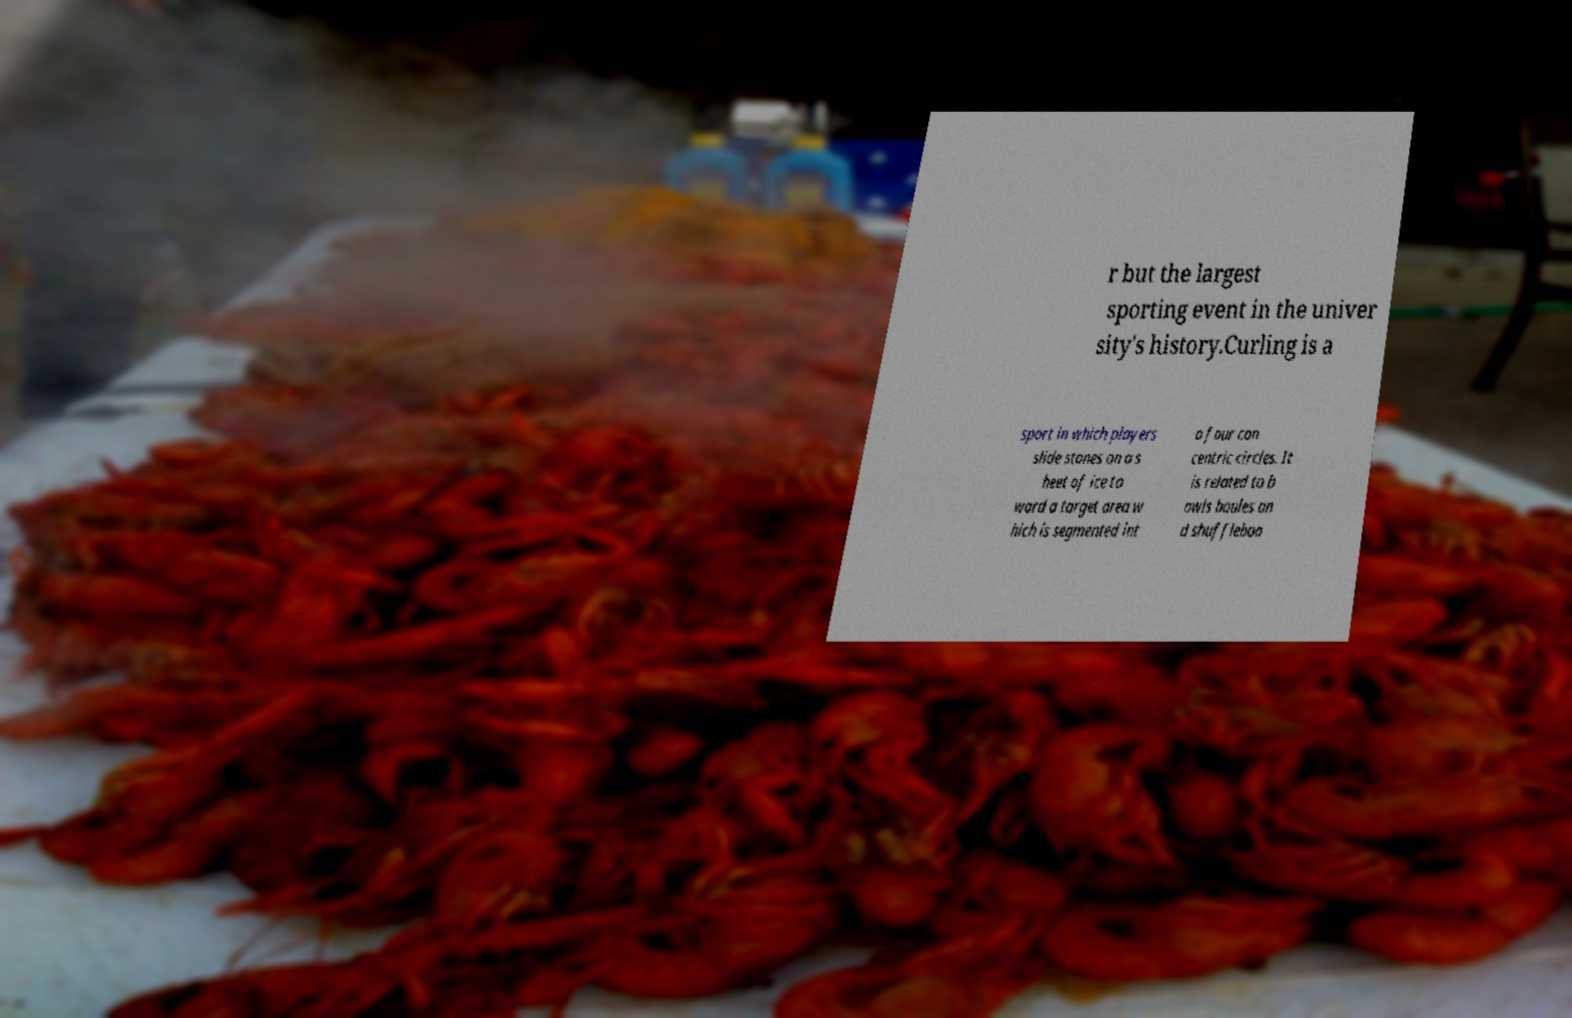Can you read and provide the text displayed in the image?This photo seems to have some interesting text. Can you extract and type it out for me? r but the largest sporting event in the univer sity's history.Curling is a sport in which players slide stones on a s heet of ice to ward a target area w hich is segmented int o four con centric circles. It is related to b owls boules an d shuffleboa 